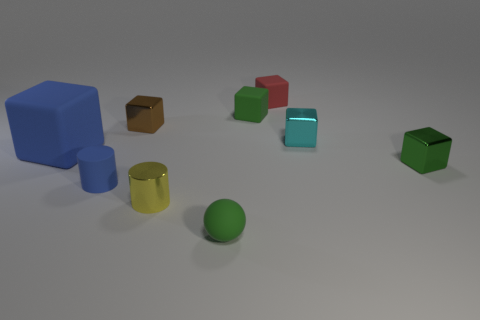Is there anything else that is the same size as the blue rubber cube?
Offer a terse response. No. There is a blue matte thing that is on the left side of the rubber cylinder; how many matte objects are behind it?
Make the answer very short. 2. Do the brown object and the yellow object have the same shape?
Provide a succinct answer. No. Is there anything else that is the same color as the sphere?
Offer a very short reply. Yes. There is a red rubber object; is its shape the same as the small green thing that is behind the large blue block?
Your answer should be very brief. Yes. What color is the small metallic thing in front of the blue rubber object in front of the object to the left of the tiny blue matte cylinder?
Your answer should be very brief. Yellow. There is a green matte object behind the green rubber sphere; is its shape the same as the tiny blue rubber object?
Your answer should be very brief. No. What is the material of the cyan cube?
Offer a very short reply. Metal. The tiny rubber object on the left side of the green rubber thing in front of the small green object to the right of the tiny red cube is what shape?
Provide a short and direct response. Cylinder. What number of other objects are the same shape as the large blue rubber thing?
Give a very brief answer. 5. 